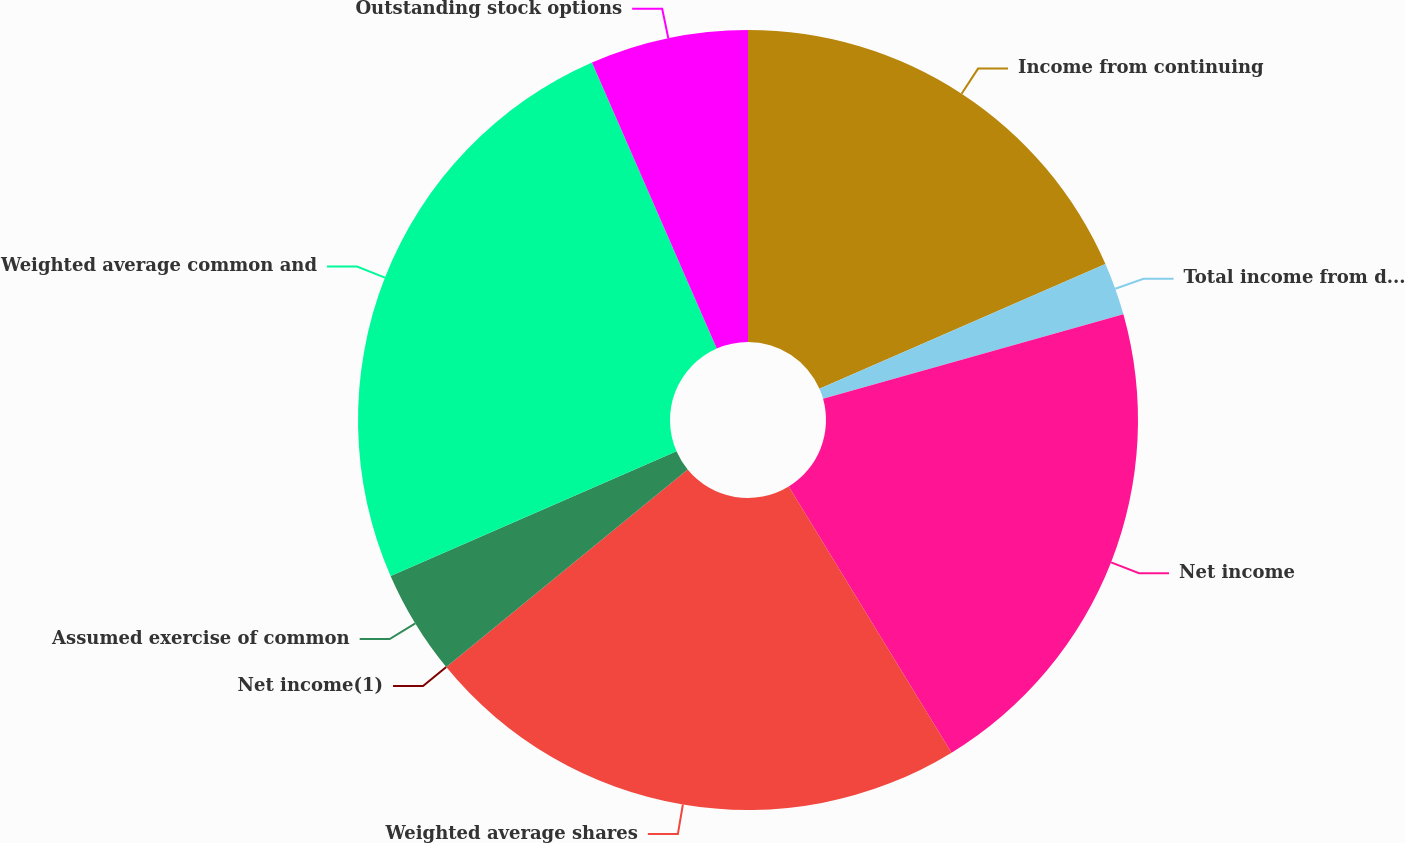Convert chart to OTSL. <chart><loc_0><loc_0><loc_500><loc_500><pie_chart><fcel>Income from continuing<fcel>Total income from discontinued<fcel>Net income<fcel>Weighted average shares<fcel>Net income(1)<fcel>Assumed exercise of common<fcel>Weighted average common and<fcel>Outstanding stock options<nl><fcel>18.45%<fcel>2.18%<fcel>20.63%<fcel>22.82%<fcel>0.0%<fcel>4.37%<fcel>25.0%<fcel>6.55%<nl></chart> 